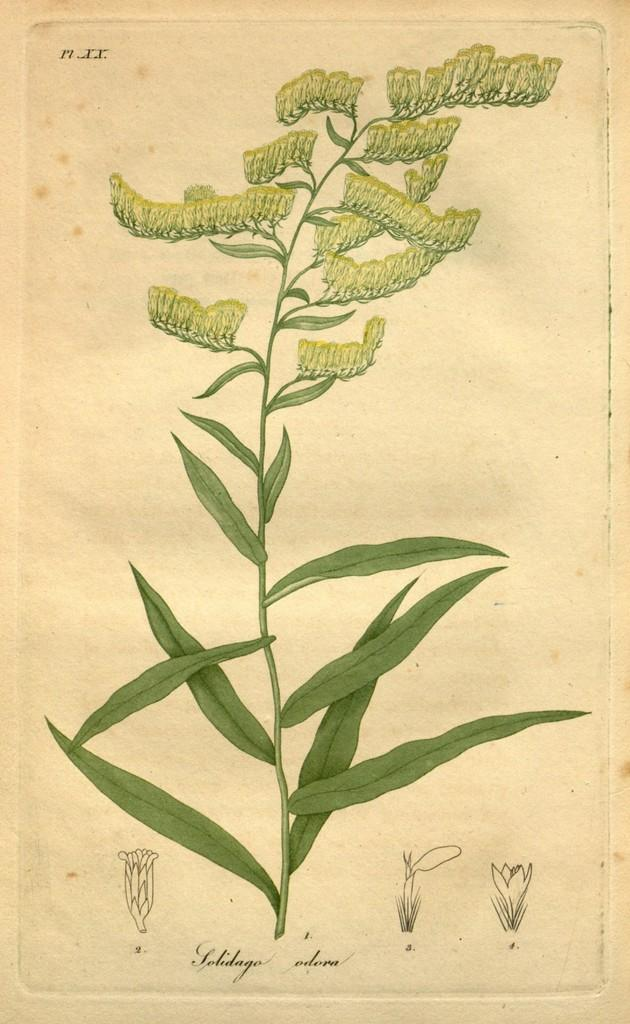What is present in the image? There is a plant in the image. Where is the plant located? The plant is on a page. Can you see a cat attempting to type on the page with the plant? No, there is no cat or typing activity present in the image. 